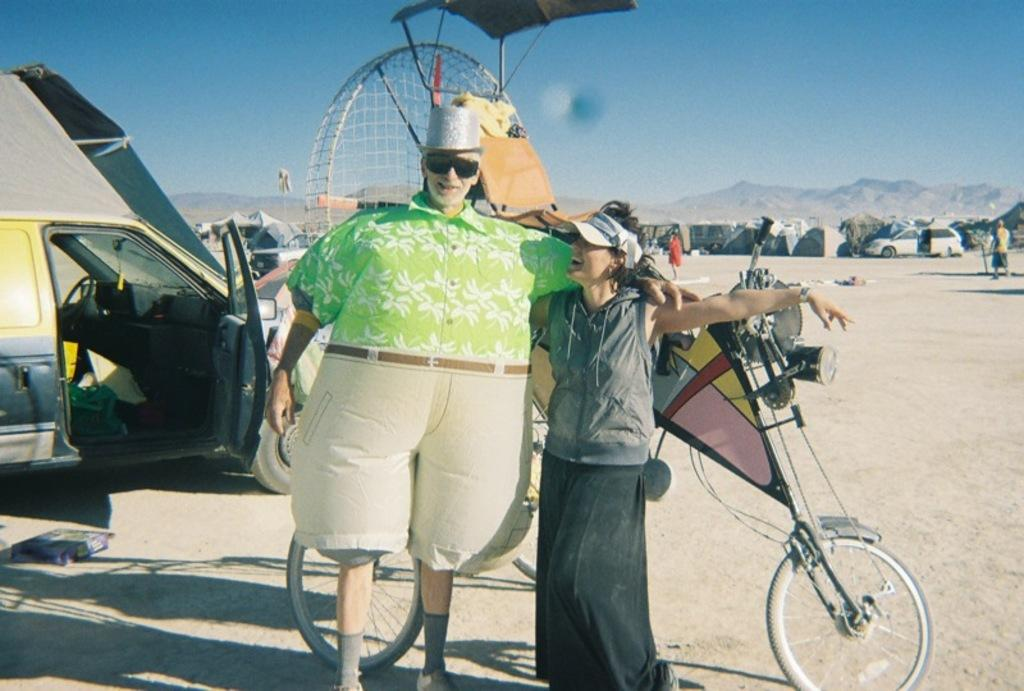How many people are in the image? There are two persons standing in the center of the image. What object can be seen besides the people? There is a bicycle in the image. What is visible in the background of the image? There is a mountain in the background of the image. What vehicle is present at the left side of the image? There is a car at the left side of the image. What flavor of ice cream is being served at the lake in the image? There is no ice cream or lake present in the image. 